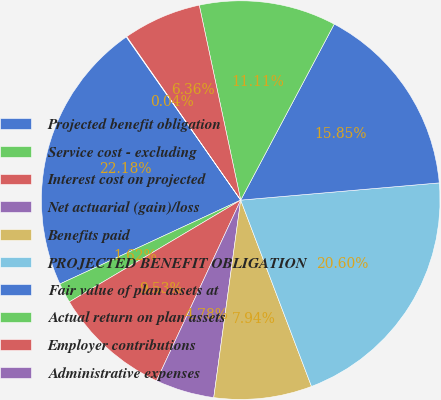Convert chart to OTSL. <chart><loc_0><loc_0><loc_500><loc_500><pie_chart><fcel>Projected benefit obligation<fcel>Service cost - excluding<fcel>Interest cost on projected<fcel>Net actuarial (gain)/loss<fcel>Benefits paid<fcel>PROJECTED BENEFIT OBLIGATION<fcel>Fair value of plan assets at<fcel>Actual return on plan assets<fcel>Employer contributions<fcel>Administrative expenses<nl><fcel>22.18%<fcel>1.62%<fcel>9.53%<fcel>4.78%<fcel>7.94%<fcel>20.6%<fcel>15.85%<fcel>11.11%<fcel>6.36%<fcel>0.04%<nl></chart> 